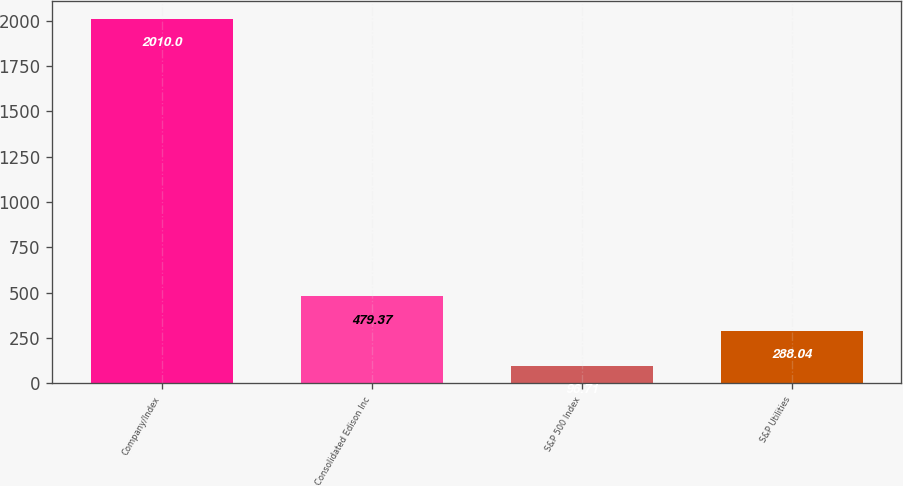Convert chart. <chart><loc_0><loc_0><loc_500><loc_500><bar_chart><fcel>Company/Index<fcel>Consolidated Edison Inc<fcel>S&P 500 Index<fcel>S&P Utilities<nl><fcel>2010<fcel>479.37<fcel>96.71<fcel>288.04<nl></chart> 